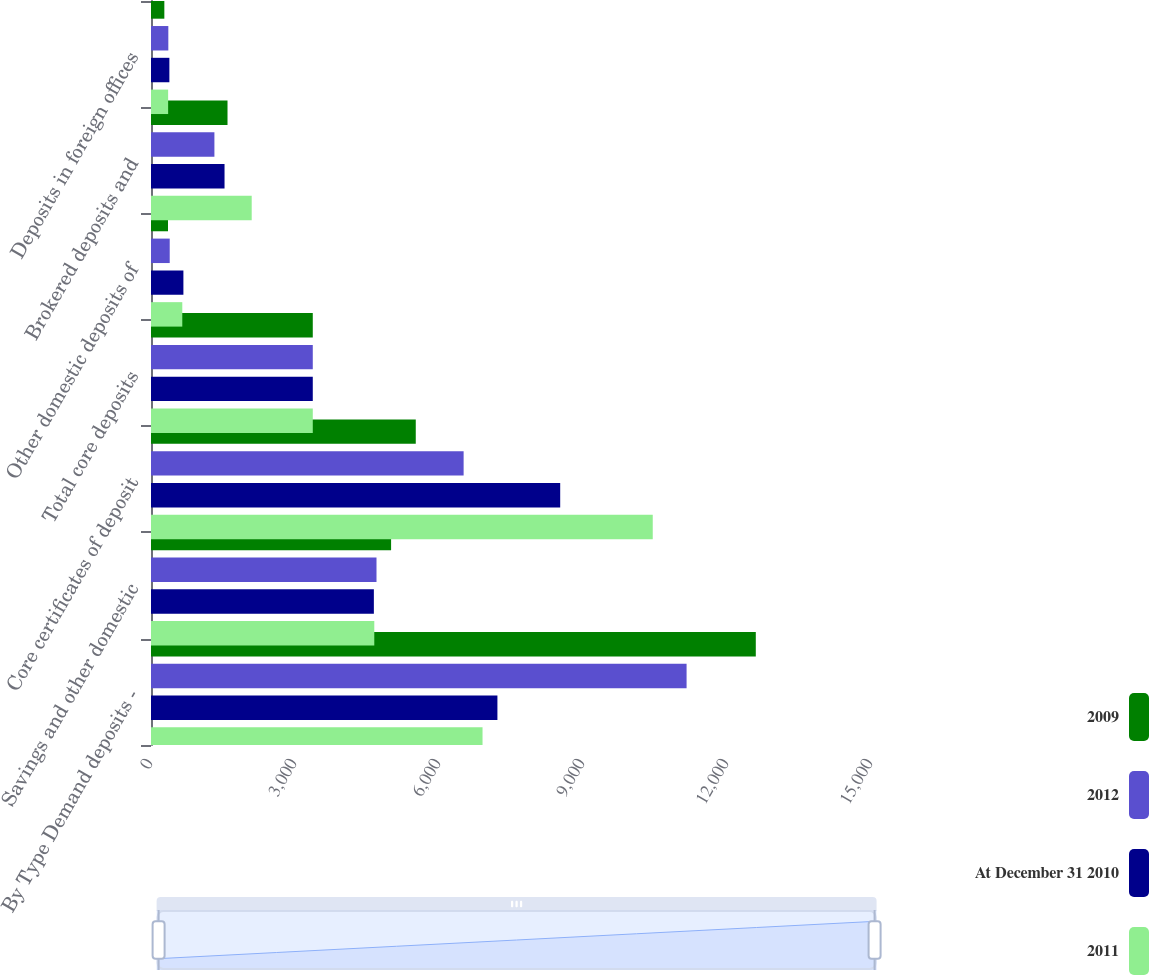<chart> <loc_0><loc_0><loc_500><loc_500><stacked_bar_chart><ecel><fcel>By Type Demand deposits -<fcel>Savings and other domestic<fcel>Core certificates of deposit<fcel>Total core deposits<fcel>Other domestic deposits of<fcel>Brokered deposits and<fcel>Deposits in foreign offices<nl><fcel>2009<fcel>12600<fcel>5002<fcel>5516<fcel>3370.5<fcel>354<fcel>1594<fcel>278<nl><fcel>2012<fcel>11158<fcel>4698<fcel>6513<fcel>3370.5<fcel>390<fcel>1321<fcel>361<nl><fcel>At December 31 2010<fcel>7217<fcel>4643<fcel>8525<fcel>3370.5<fcel>675<fcel>1532<fcel>383<nl><fcel>2011<fcel>6907<fcel>4652<fcel>10453<fcel>3370.5<fcel>652<fcel>2098<fcel>357<nl></chart> 